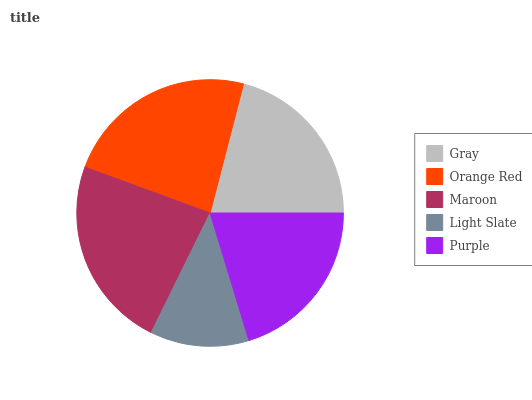Is Light Slate the minimum?
Answer yes or no. Yes. Is Orange Red the maximum?
Answer yes or no. Yes. Is Maroon the minimum?
Answer yes or no. No. Is Maroon the maximum?
Answer yes or no. No. Is Orange Red greater than Maroon?
Answer yes or no. Yes. Is Maroon less than Orange Red?
Answer yes or no. Yes. Is Maroon greater than Orange Red?
Answer yes or no. No. Is Orange Red less than Maroon?
Answer yes or no. No. Is Gray the high median?
Answer yes or no. Yes. Is Gray the low median?
Answer yes or no. Yes. Is Purple the high median?
Answer yes or no. No. Is Light Slate the low median?
Answer yes or no. No. 